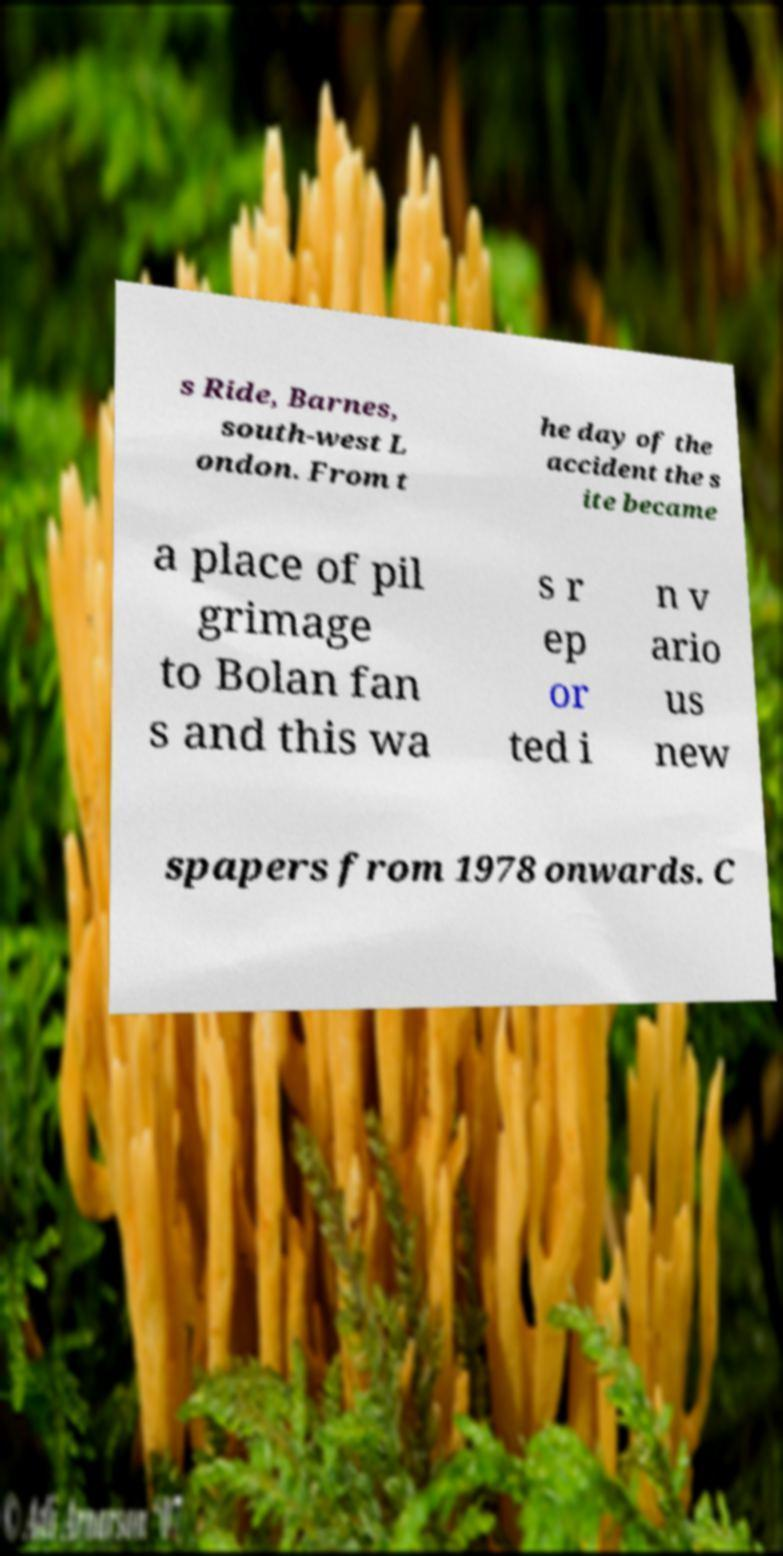There's text embedded in this image that I need extracted. Can you transcribe it verbatim? s Ride, Barnes, south-west L ondon. From t he day of the accident the s ite became a place of pil grimage to Bolan fan s and this wa s r ep or ted i n v ario us new spapers from 1978 onwards. C 